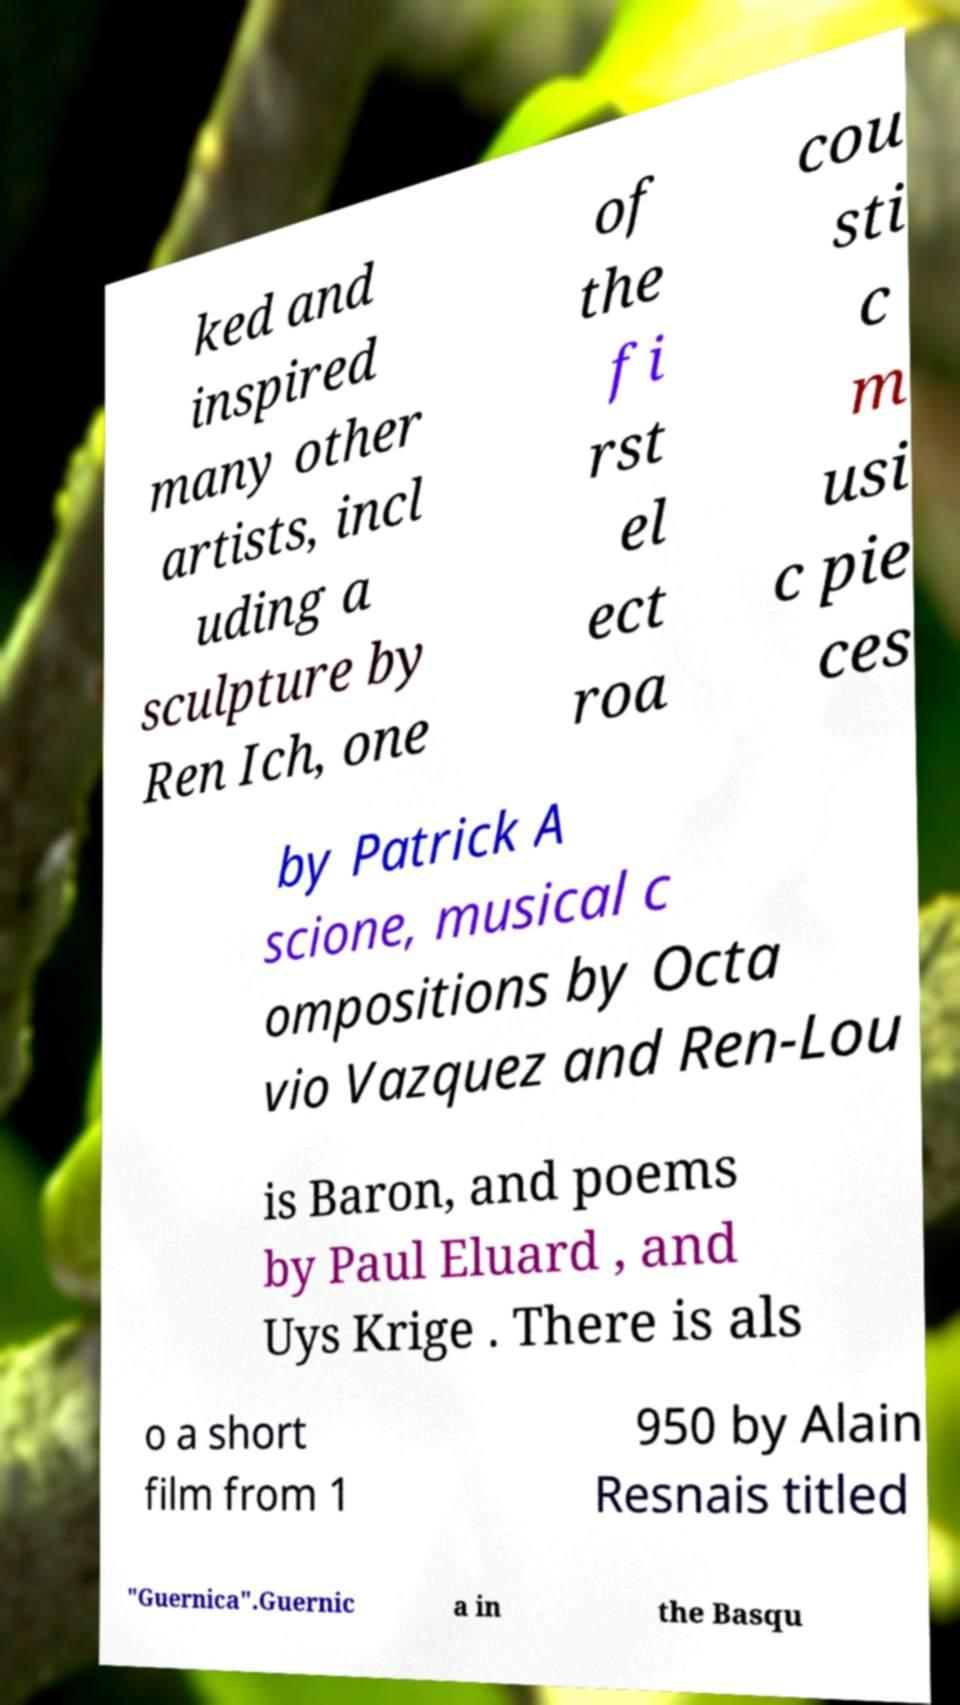There's text embedded in this image that I need extracted. Can you transcribe it verbatim? ked and inspired many other artists, incl uding a sculpture by Ren Ich, one of the fi rst el ect roa cou sti c m usi c pie ces by Patrick A scione, musical c ompositions by Octa vio Vazquez and Ren-Lou is Baron, and poems by Paul Eluard , and Uys Krige . There is als o a short film from 1 950 by Alain Resnais titled "Guernica".Guernic a in the Basqu 